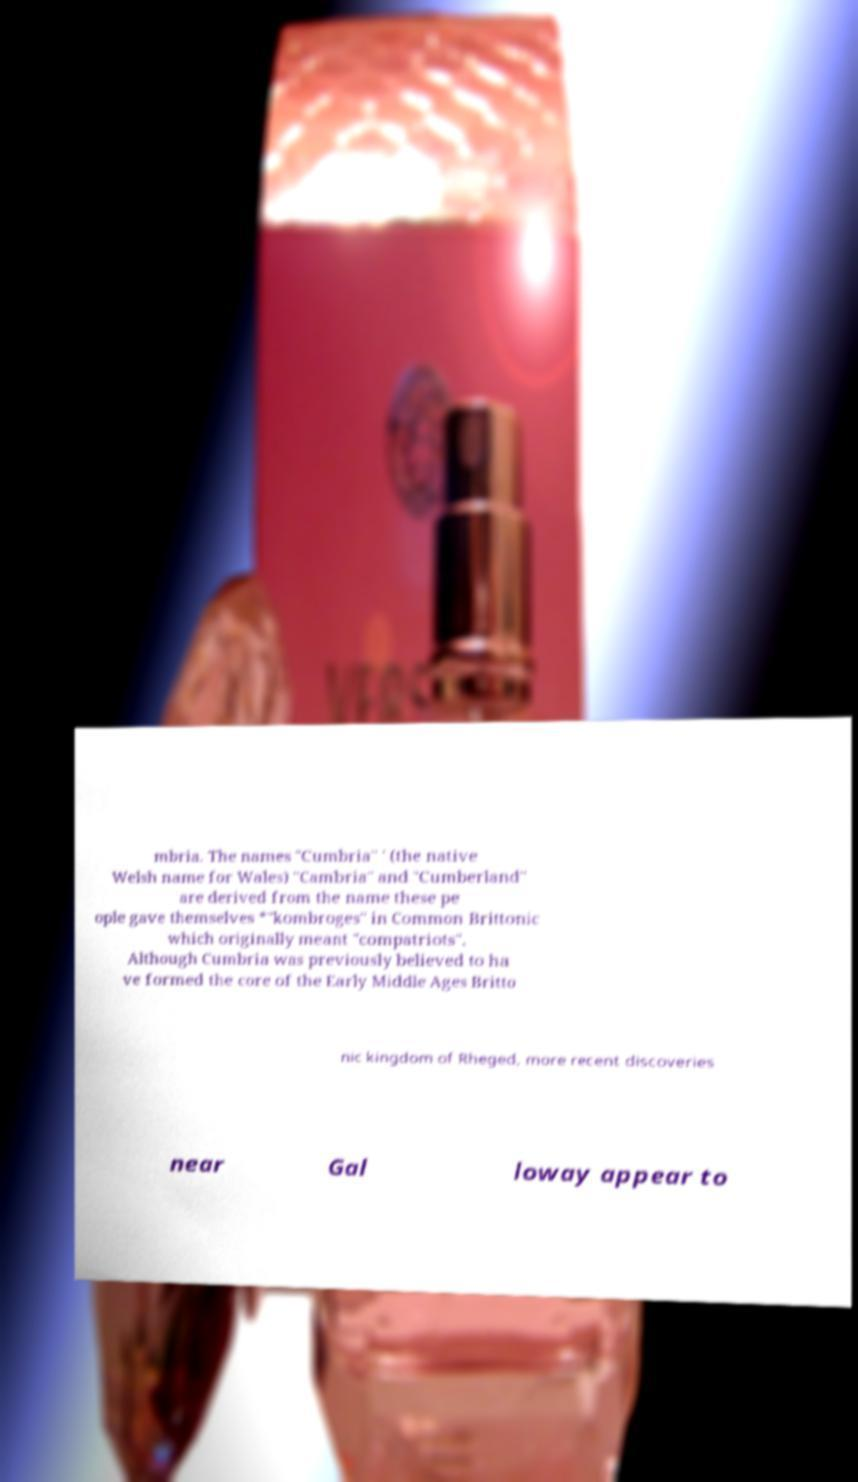Can you accurately transcribe the text from the provided image for me? mbria. The names "Cumbria" ' (the native Welsh name for Wales) "Cambria" and "Cumberland" are derived from the name these pe ople gave themselves *"kombroges" in Common Brittonic which originally meant "compatriots". Although Cumbria was previously believed to ha ve formed the core of the Early Middle Ages Britto nic kingdom of Rheged, more recent discoveries near Gal loway appear to 